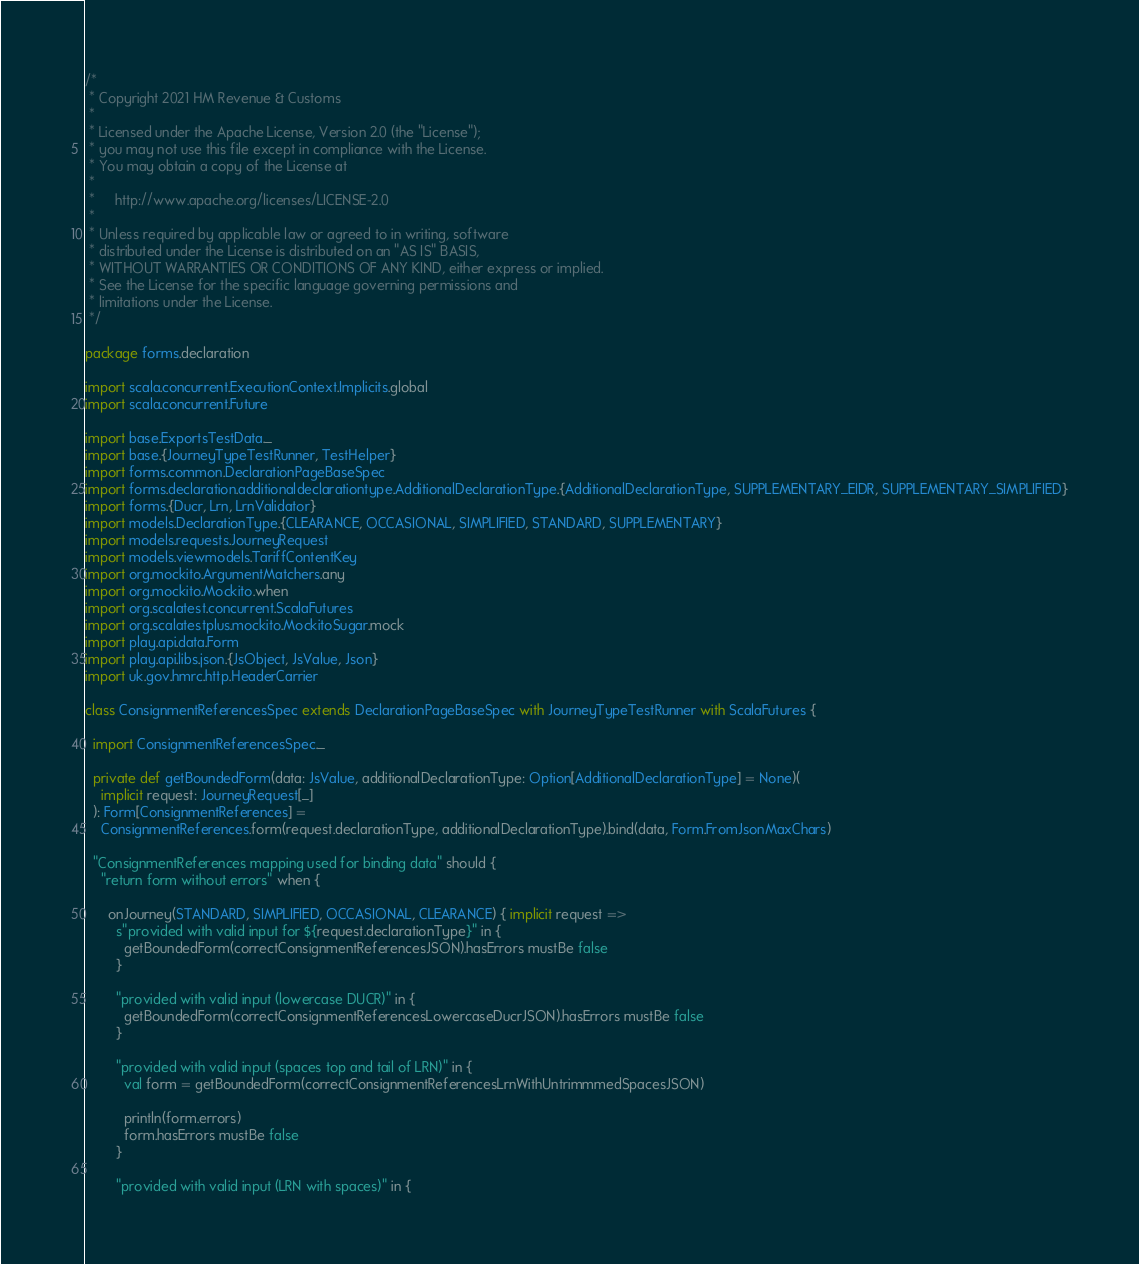Convert code to text. <code><loc_0><loc_0><loc_500><loc_500><_Scala_>/*
 * Copyright 2021 HM Revenue & Customs
 *
 * Licensed under the Apache License, Version 2.0 (the "License");
 * you may not use this file except in compliance with the License.
 * You may obtain a copy of the License at
 *
 *     http://www.apache.org/licenses/LICENSE-2.0
 *
 * Unless required by applicable law or agreed to in writing, software
 * distributed under the License is distributed on an "AS IS" BASIS,
 * WITHOUT WARRANTIES OR CONDITIONS OF ANY KIND, either express or implied.
 * See the License for the specific language governing permissions and
 * limitations under the License.
 */

package forms.declaration

import scala.concurrent.ExecutionContext.Implicits.global
import scala.concurrent.Future

import base.ExportsTestData._
import base.{JourneyTypeTestRunner, TestHelper}
import forms.common.DeclarationPageBaseSpec
import forms.declaration.additionaldeclarationtype.AdditionalDeclarationType.{AdditionalDeclarationType, SUPPLEMENTARY_EIDR, SUPPLEMENTARY_SIMPLIFIED}
import forms.{Ducr, Lrn, LrnValidator}
import models.DeclarationType.{CLEARANCE, OCCASIONAL, SIMPLIFIED, STANDARD, SUPPLEMENTARY}
import models.requests.JourneyRequest
import models.viewmodels.TariffContentKey
import org.mockito.ArgumentMatchers.any
import org.mockito.Mockito.when
import org.scalatest.concurrent.ScalaFutures
import org.scalatestplus.mockito.MockitoSugar.mock
import play.api.data.Form
import play.api.libs.json.{JsObject, JsValue, Json}
import uk.gov.hmrc.http.HeaderCarrier

class ConsignmentReferencesSpec extends DeclarationPageBaseSpec with JourneyTypeTestRunner with ScalaFutures {

  import ConsignmentReferencesSpec._

  private def getBoundedForm(data: JsValue, additionalDeclarationType: Option[AdditionalDeclarationType] = None)(
    implicit request: JourneyRequest[_]
  ): Form[ConsignmentReferences] =
    ConsignmentReferences.form(request.declarationType, additionalDeclarationType).bind(data, Form.FromJsonMaxChars)

  "ConsignmentReferences mapping used for binding data" should {
    "return form without errors" when {

      onJourney(STANDARD, SIMPLIFIED, OCCASIONAL, CLEARANCE) { implicit request =>
        s"provided with valid input for ${request.declarationType}" in {
          getBoundedForm(correctConsignmentReferencesJSON).hasErrors mustBe false
        }

        "provided with valid input (lowercase DUCR)" in {
          getBoundedForm(correctConsignmentReferencesLowercaseDucrJSON).hasErrors mustBe false
        }

        "provided with valid input (spaces top and tail of LRN)" in {
          val form = getBoundedForm(correctConsignmentReferencesLrnWithUntrimmmedSpacesJSON)

          println(form.errors)
          form.hasErrors mustBe false
        }

        "provided with valid input (LRN with spaces)" in {</code> 